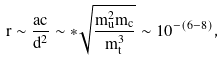Convert formula to latex. <formula><loc_0><loc_0><loc_500><loc_500>r \sim \frac { a c } { d ^ { 2 } } \sim * \sqrt { \frac { m _ { u } ^ { 2 } m _ { c } } { m _ { t } ^ { 3 } } } \sim 1 0 ^ { - ( 6 - 8 ) } ,</formula> 